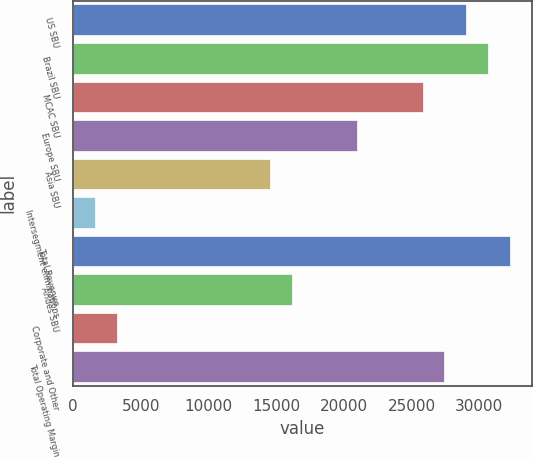Convert chart to OTSL. <chart><loc_0><loc_0><loc_500><loc_500><bar_chart><fcel>US SBU<fcel>Brazil SBU<fcel>MCAC SBU<fcel>Europe SBU<fcel>Asia SBU<fcel>Intersegment eliminations<fcel>Total Revenue<fcel>Andes SBU<fcel>Corporate and Other<fcel>Total Operating Margin<nl><fcel>29023<fcel>30635.3<fcel>25798.2<fcel>20961.1<fcel>14511.6<fcel>1612.62<fcel>32247.7<fcel>16124<fcel>3224.99<fcel>27410.6<nl></chart> 